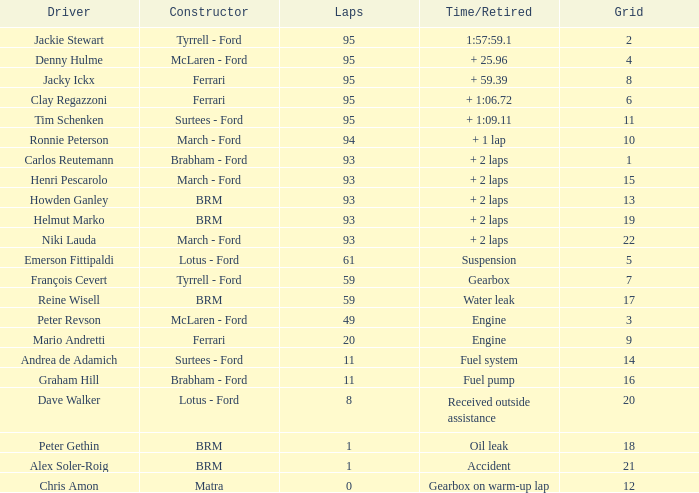With a grid exceeding 14, a time/retired over 2 laps, and helmut marko as the driver, what is the highest number of laps possible? 93.0. 